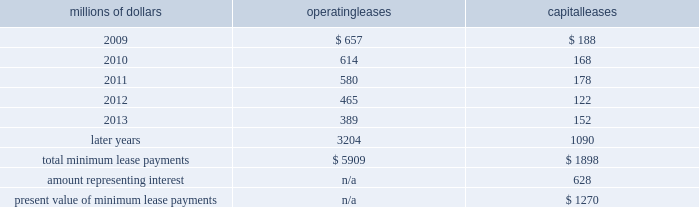14 .
Leases we lease certain locomotives , freight cars , and other property .
The consolidated statement of financial position as of december 31 , 2008 and 2007 included $ 2024 million , net of $ 869 million of amortization , and $ 2062 million , net of $ 887 million of amortization , respectively , for properties held under capital leases .
A charge to income resulting from the amortization for assets held under capital leases is included within depreciation expense in our consolidated statements of income .
Future minimum lease payments for operating and capital leases with initial or remaining non-cancelable lease terms in excess of one year as of december 31 , 2008 were as follows : millions of dollars operating leases capital leases .
The majority of capital lease payments relate to locomotives .
Rent expense for operating leases with terms exceeding one month was $ 747 million in 2008 , $ 810 million in 2007 , and $ 798 million in 2006 .
When cash rental payments are not made on a straight-line basis , we recognize variable rental expense on a straight-line basis over the lease term .
Contingent rentals and sub-rentals are not significant .
15 .
Commitments and contingencies asserted and unasserted claims 2013 various claims and lawsuits are pending against us and certain of our subsidiaries .
We cannot fully determine the effect of all asserted and unasserted claims on our consolidated results of operations , financial condition , or liquidity ; however , to the extent possible , where asserted and unasserted claims are considered probable and where such claims can be reasonably estimated , we have recorded a liability .
We do not expect that any known lawsuits , claims , environmental costs , commitments , contingent liabilities , or guarantees will have a material adverse effect on our consolidated results of operations , financial condition , or liquidity after taking into account liabilities and insurance recoveries previously recorded for these matters .
Personal injury 2013 the cost of personal injuries to employees and others related to our activities is charged to expense based on estimates of the ultimate cost and number of incidents each year .
We use third-party actuaries to assist us in measuring the expense and liability , including unasserted claims .
The federal employers 2019 liability act ( fela ) governs compensation for work-related accidents .
Under fela , damages are assessed based on a finding of fault through litigation or out-of-court settlements .
We offer a comprehensive variety of services and rehabilitation programs for employees who are injured at our personal injury liability is discounted to present value using applicable u.s .
Treasury rates .
Approximately 88% ( 88 % ) of the recorded liability related to asserted claims , and approximately 12% ( 12 % ) related to unasserted claims at december 31 , 2008 .
Because of the uncertainty surrounding the ultimate outcome of personal injury claims , it is reasonably possible that future costs to settle these claims may range from .
What percentage of total minimum lease payments are capital leases? 
Computations: (1898 / (5909 + 1898))
Answer: 0.24312. 